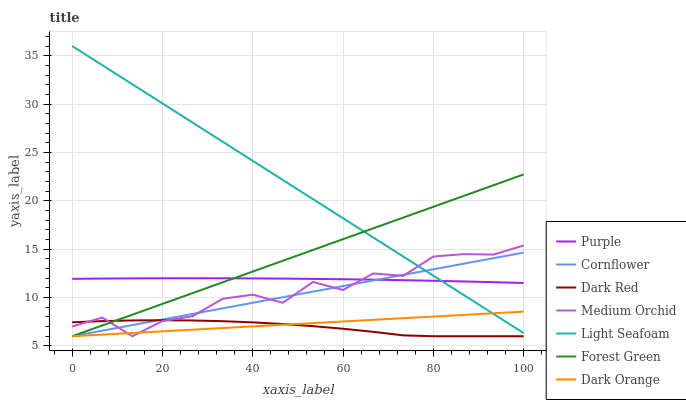Does Dark Red have the minimum area under the curve?
Answer yes or no. Yes. Does Light Seafoam have the maximum area under the curve?
Answer yes or no. Yes. Does Dark Orange have the minimum area under the curve?
Answer yes or no. No. Does Dark Orange have the maximum area under the curve?
Answer yes or no. No. Is Dark Orange the smoothest?
Answer yes or no. Yes. Is Medium Orchid the roughest?
Answer yes or no. Yes. Is Purple the smoothest?
Answer yes or no. No. Is Purple the roughest?
Answer yes or no. No. Does Cornflower have the lowest value?
Answer yes or no. Yes. Does Purple have the lowest value?
Answer yes or no. No. Does Light Seafoam have the highest value?
Answer yes or no. Yes. Does Dark Orange have the highest value?
Answer yes or no. No. Is Dark Red less than Purple?
Answer yes or no. Yes. Is Purple greater than Dark Red?
Answer yes or no. Yes. Does Forest Green intersect Purple?
Answer yes or no. Yes. Is Forest Green less than Purple?
Answer yes or no. No. Is Forest Green greater than Purple?
Answer yes or no. No. Does Dark Red intersect Purple?
Answer yes or no. No. 